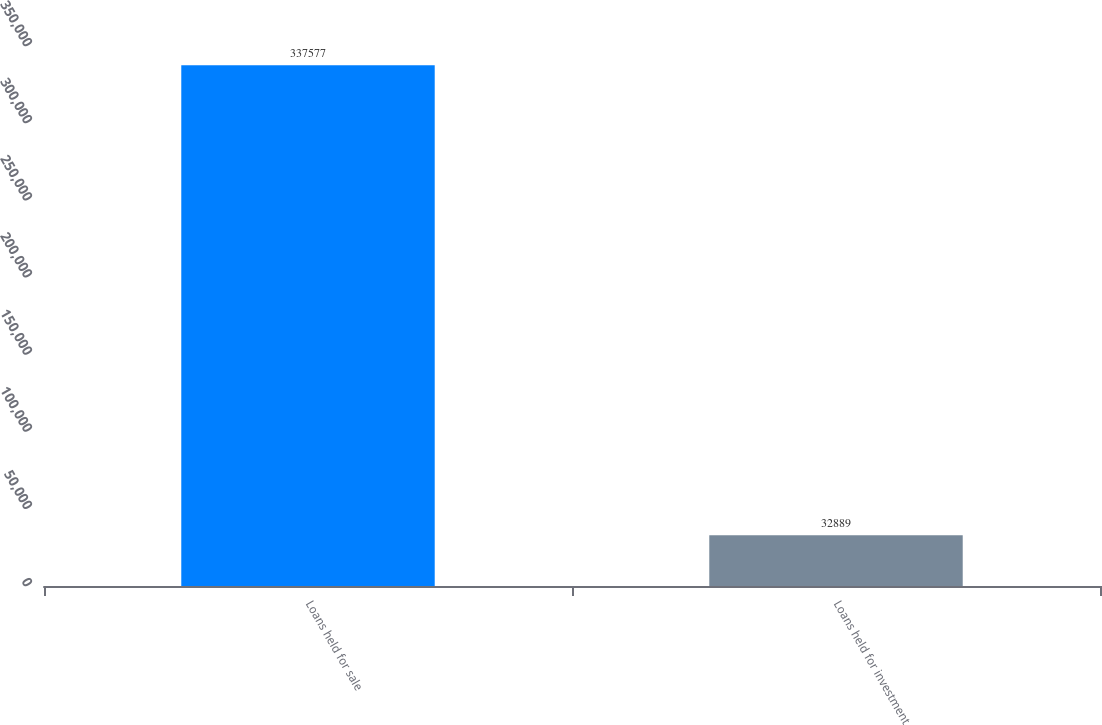Convert chart. <chart><loc_0><loc_0><loc_500><loc_500><bar_chart><fcel>Loans held for sale<fcel>Loans held for investment<nl><fcel>337577<fcel>32889<nl></chart> 